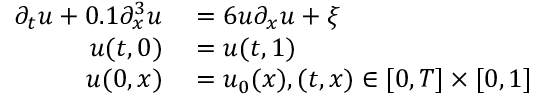<formula> <loc_0><loc_0><loc_500><loc_500>\begin{array} { r l } { \partial _ { t } u + 0 . 1 \partial _ { x } ^ { 3 } u } & = 6 u \partial _ { x } u + \xi } \\ { u ( t , 0 ) } & = u ( t , 1 ) } \\ { u ( 0 , x ) } & = u _ { 0 } ( x ) , ( t , x ) \in [ 0 , T ] \times [ 0 , 1 ] } \end{array}</formula> 